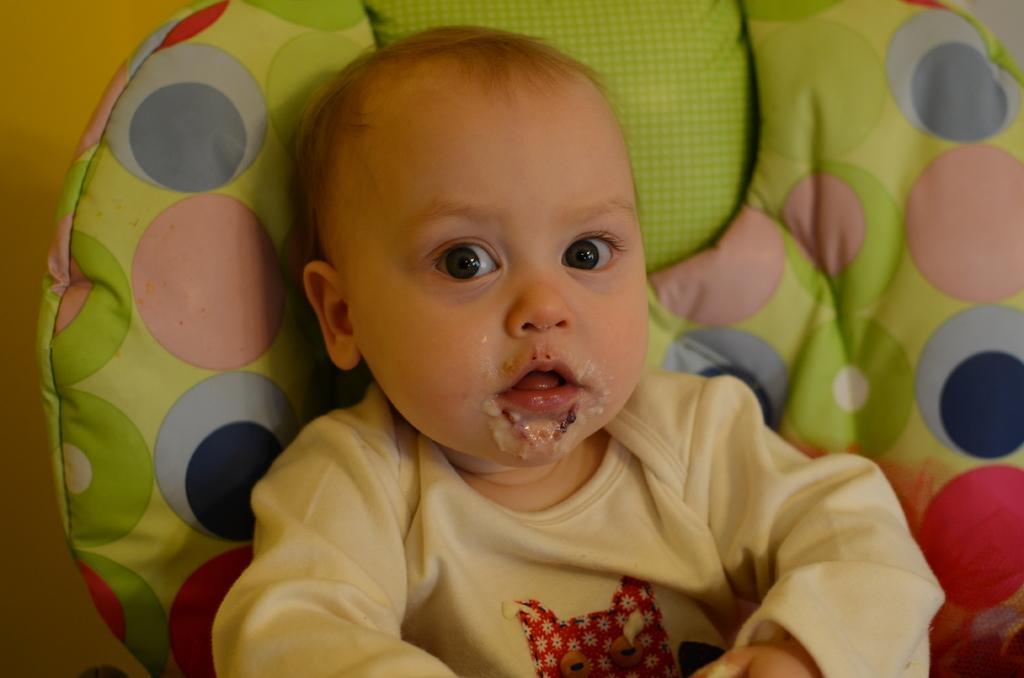Could you give a brief overview of what you see in this image? In this image we can see a baby boy sitting on a sofa. He is wearing a T-shirt. 